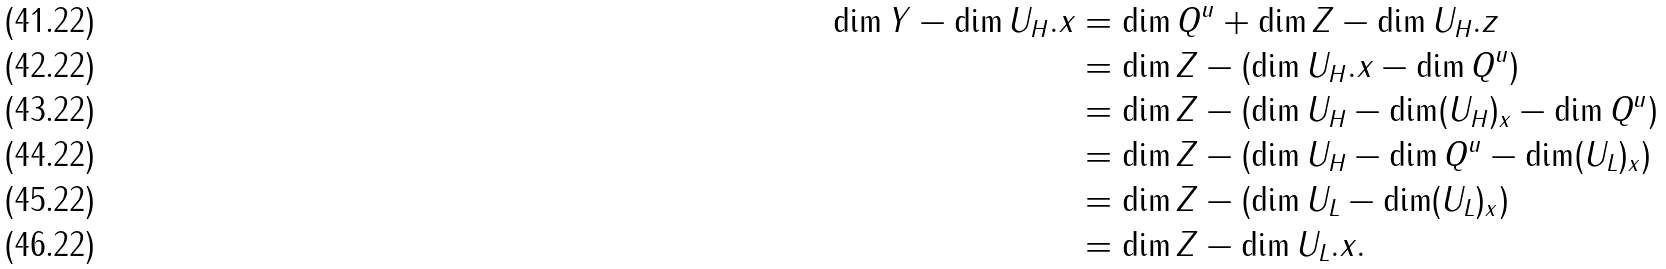Convert formula to latex. <formula><loc_0><loc_0><loc_500><loc_500>\dim Y - \dim U _ { H } . x & = \dim Q ^ { u } + \dim Z - \dim U _ { H } . z \\ & = \dim Z - ( \dim U _ { H } . x - \dim Q ^ { u } ) \\ & = \dim Z - ( \dim U _ { H } - \dim ( U _ { H } ) _ { x } - \dim Q ^ { u } ) \\ & = \dim Z - ( \dim U _ { H } - \dim Q ^ { u } - \dim ( U _ { L } ) _ { x } ) \\ & = \dim Z - ( \dim U _ { L } - \dim ( U _ { L } ) _ { x } ) \\ & = \dim Z - \dim U _ { L } . x .</formula> 